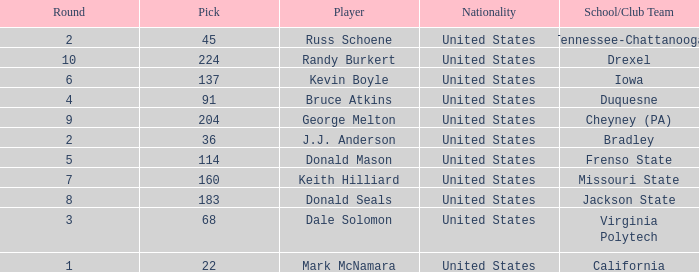What is the nationality of the player from Drexel who had a pick larger than 183? United States. Would you be able to parse every entry in this table? {'header': ['Round', 'Pick', 'Player', 'Nationality', 'School/Club Team'], 'rows': [['2', '45', 'Russ Schoene', 'United States', 'Tennessee-Chattanooga'], ['10', '224', 'Randy Burkert', 'United States', 'Drexel'], ['6', '137', 'Kevin Boyle', 'United States', 'Iowa'], ['4', '91', 'Bruce Atkins', 'United States', 'Duquesne'], ['9', '204', 'George Melton', 'United States', 'Cheyney (PA)'], ['2', '36', 'J.J. Anderson', 'United States', 'Bradley'], ['5', '114', 'Donald Mason', 'United States', 'Frenso State'], ['7', '160', 'Keith Hilliard', 'United States', 'Missouri State'], ['8', '183', 'Donald Seals', 'United States', 'Jackson State'], ['3', '68', 'Dale Solomon', 'United States', 'Virginia Polytech'], ['1', '22', 'Mark McNamara', 'United States', 'California']]} 